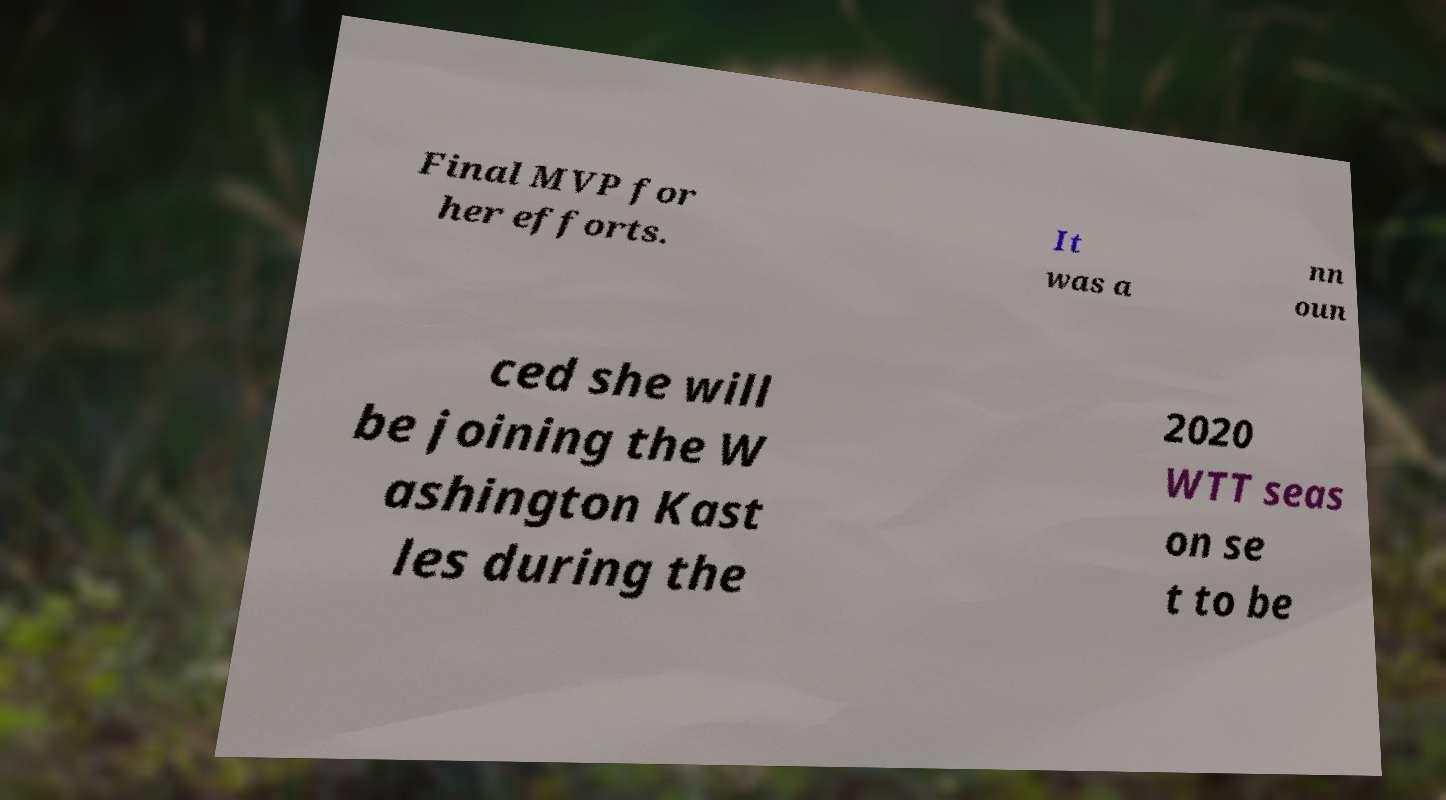Could you extract and type out the text from this image? Final MVP for her efforts. It was a nn oun ced she will be joining the W ashington Kast les during the 2020 WTT seas on se t to be 